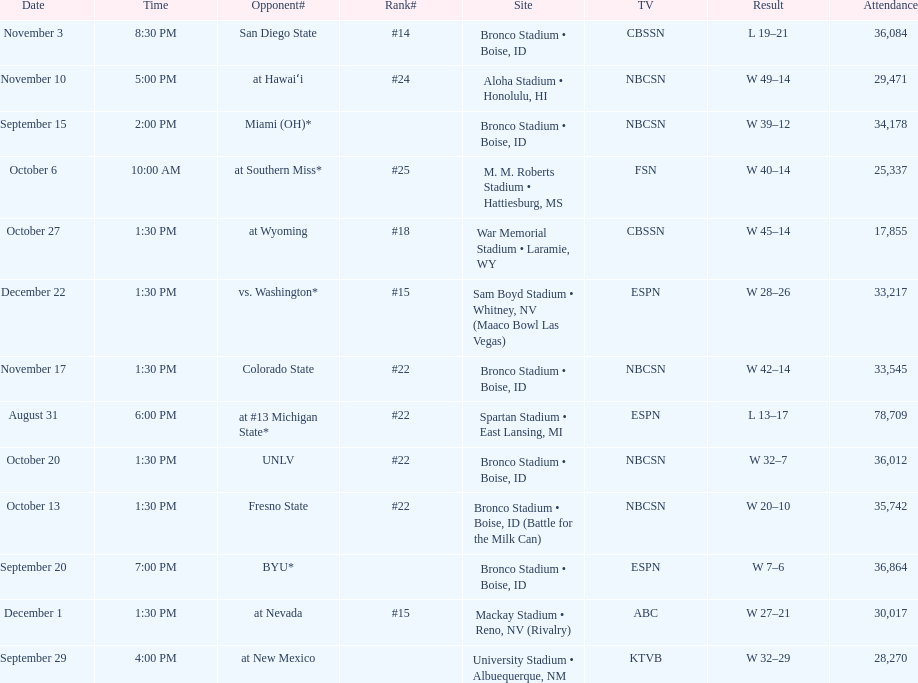What is the point disparity in the contest against michigan state? 4. 